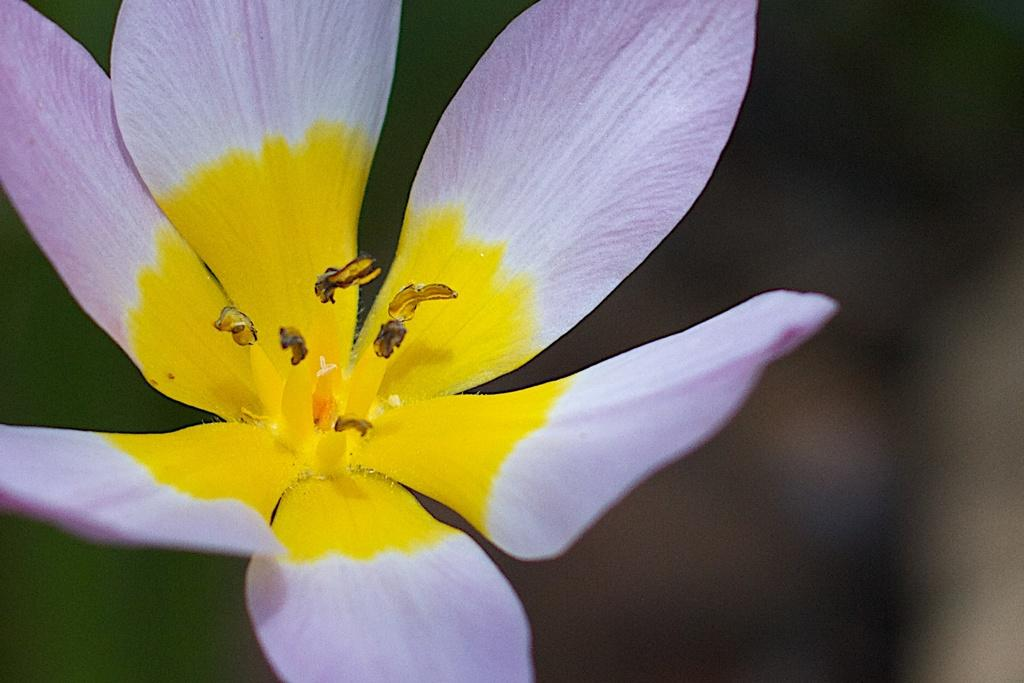What is the main subject of the picture? The main subject of the picture is a flower. What colors can be seen on the flower? The flower has white, purple, and yellow colors. How is the flower positioned in the image? The flower is blurred in the background. What type of offer is the flower making to the family in the image? There is no family present in the image, and the flower is not making any offers. 